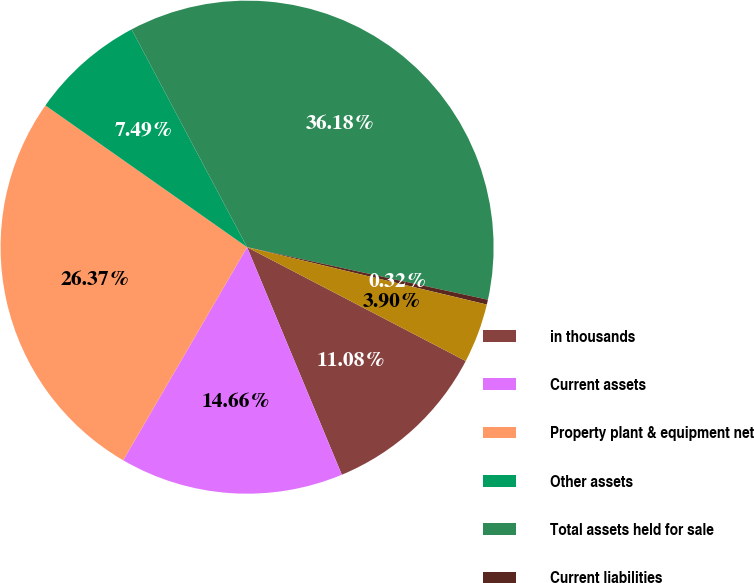Convert chart to OTSL. <chart><loc_0><loc_0><loc_500><loc_500><pie_chart><fcel>in thousands<fcel>Current assets<fcel>Property plant & equipment net<fcel>Other assets<fcel>Total assets held for sale<fcel>Current liabilities<fcel>Total liabilities of assets<nl><fcel>11.08%<fcel>14.66%<fcel>26.37%<fcel>7.49%<fcel>36.18%<fcel>0.32%<fcel>3.9%<nl></chart> 